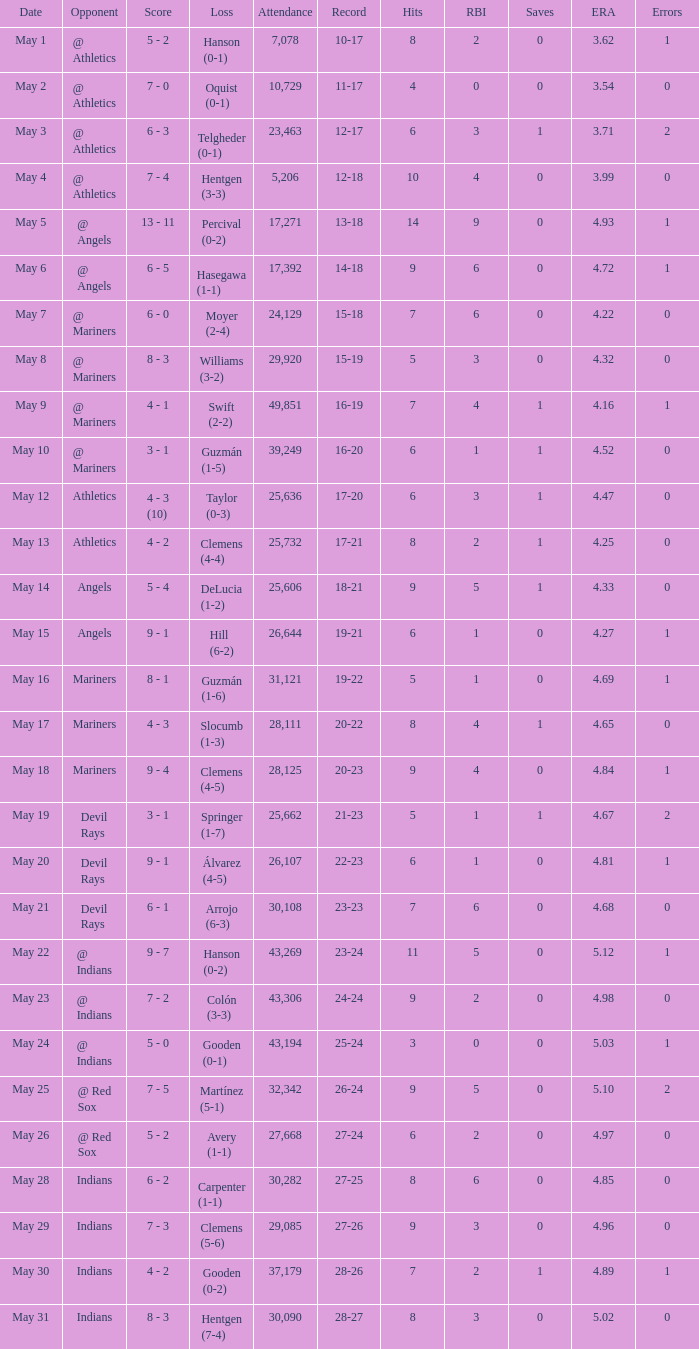Who lost on May 31? Hentgen (7-4). 